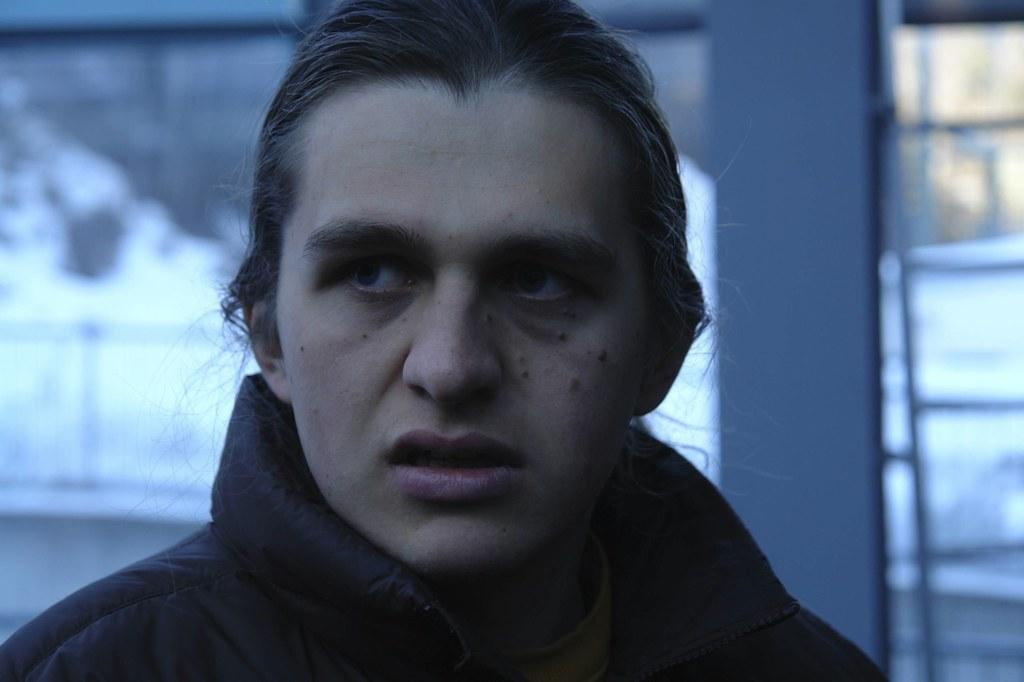Who is present in the image? There is a man in the image. What is the man wearing in the image? The man is wearing a black coat. What can be seen in the background of the image? There appears to be a building in the background of the image. What type of scissors is the man holding in the image? There are no scissors present in the image; the man is not holding any objects. 